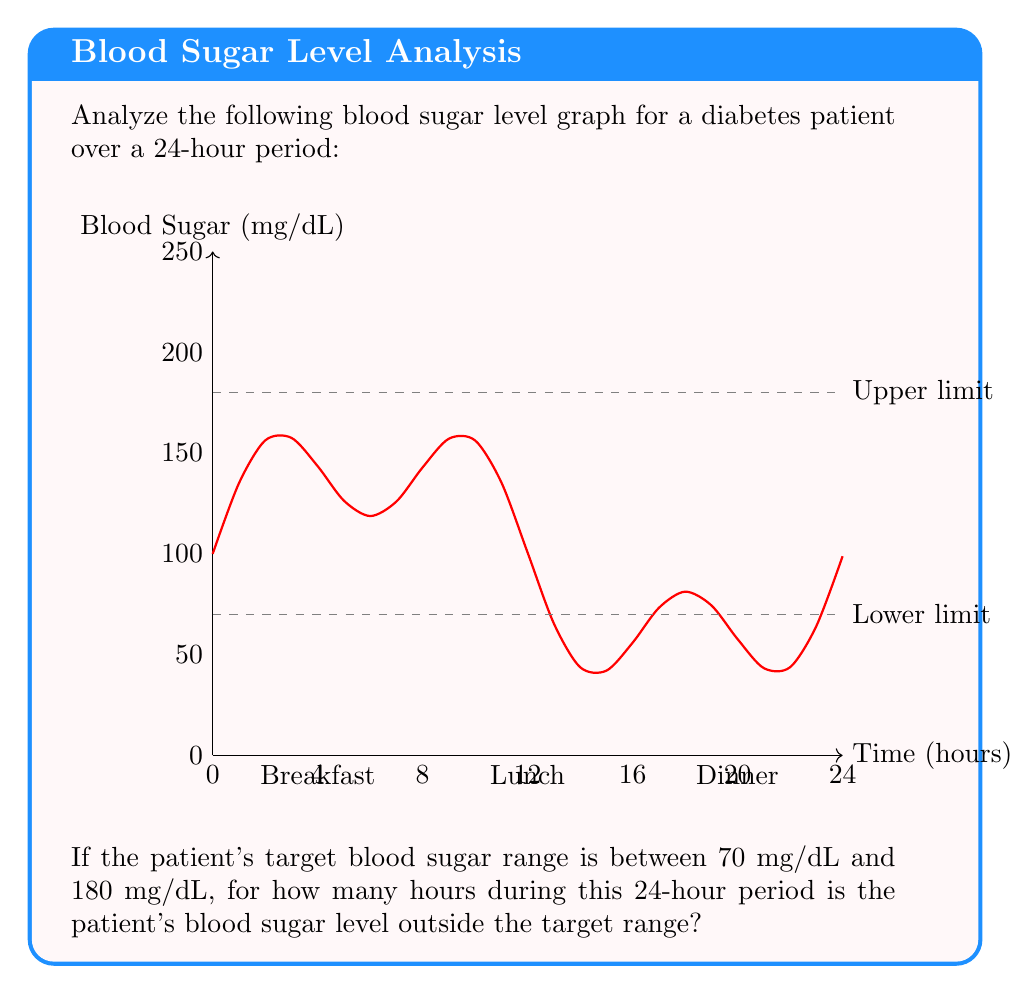Can you solve this math problem? To solve this problem, we need to follow these steps:

1) Identify the points where the blood sugar curve intersects the upper (180 mg/dL) and lower (70 mg/dL) limits.

2) From the graph, we can see that the curve intersects the upper limit twice and the lower limit twice.

3) Let's approximate the times of these intersections:
   - Upper limit: around 5.5 hours and 17.5 hours
   - Lower limit: around 11 hours and 23 hours

4) Calculate the time periods when the blood sugar is above 180 mg/dL:
   $$(17.5 - 5.5) = 12$$ hours

5) Calculate the time periods when the blood sugar is below 70 mg/dL:
   $$(24 - 23) + (11 - 0) = 1 + 11 = 12$$ hours

6) Sum up the total time outside the target range:
   $$12 + 12 = 24$$ hours

Therefore, the patient's blood sugar level is outside the target range for approximately 6 hours during this 24-hour period.
Answer: 6 hours 